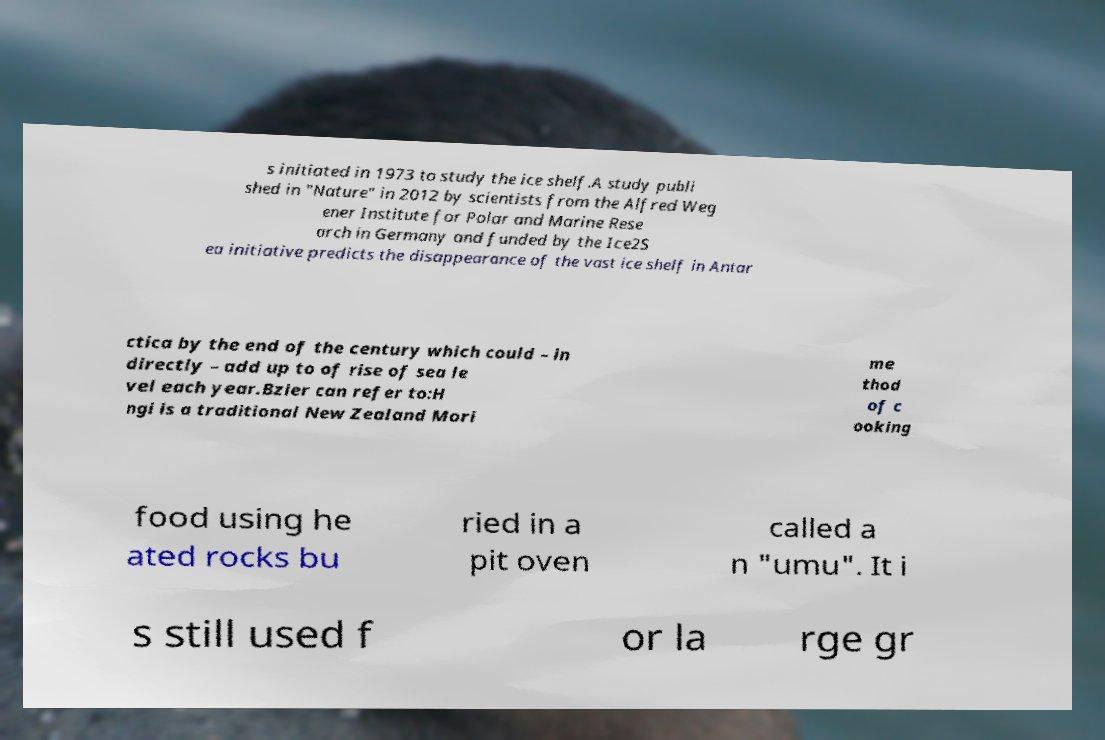There's text embedded in this image that I need extracted. Can you transcribe it verbatim? s initiated in 1973 to study the ice shelf.A study publi shed in "Nature" in 2012 by scientists from the Alfred Weg ener Institute for Polar and Marine Rese arch in Germany and funded by the Ice2S ea initiative predicts the disappearance of the vast ice shelf in Antar ctica by the end of the century which could – in directly – add up to of rise of sea le vel each year.Bzier can refer to:H ngi is a traditional New Zealand Mori me thod of c ooking food using he ated rocks bu ried in a pit oven called a n "umu". It i s still used f or la rge gr 